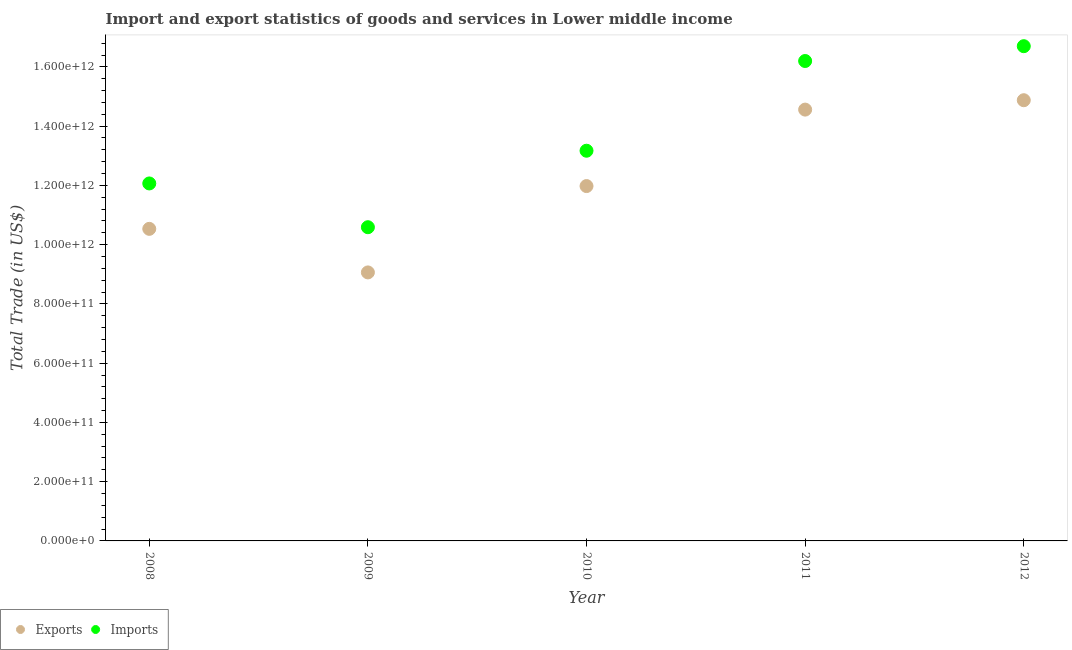Is the number of dotlines equal to the number of legend labels?
Give a very brief answer. Yes. What is the export of goods and services in 2008?
Your response must be concise. 1.05e+12. Across all years, what is the maximum export of goods and services?
Give a very brief answer. 1.49e+12. Across all years, what is the minimum export of goods and services?
Give a very brief answer. 9.06e+11. In which year was the export of goods and services maximum?
Provide a succinct answer. 2012. In which year was the imports of goods and services minimum?
Provide a short and direct response. 2009. What is the total export of goods and services in the graph?
Your answer should be compact. 6.10e+12. What is the difference between the export of goods and services in 2010 and that in 2011?
Offer a very short reply. -2.58e+11. What is the difference between the imports of goods and services in 2011 and the export of goods and services in 2008?
Your response must be concise. 5.67e+11. What is the average export of goods and services per year?
Provide a short and direct response. 1.22e+12. In the year 2012, what is the difference between the imports of goods and services and export of goods and services?
Keep it short and to the point. 1.82e+11. In how many years, is the export of goods and services greater than 840000000000 US$?
Provide a short and direct response. 5. What is the ratio of the export of goods and services in 2008 to that in 2012?
Your answer should be very brief. 0.71. What is the difference between the highest and the second highest export of goods and services?
Keep it short and to the point. 3.17e+1. What is the difference between the highest and the lowest export of goods and services?
Your response must be concise. 5.81e+11. Is the export of goods and services strictly greater than the imports of goods and services over the years?
Keep it short and to the point. No. How many dotlines are there?
Your answer should be compact. 2. How many years are there in the graph?
Provide a short and direct response. 5. What is the difference between two consecutive major ticks on the Y-axis?
Keep it short and to the point. 2.00e+11. Does the graph contain any zero values?
Provide a succinct answer. No. Where does the legend appear in the graph?
Keep it short and to the point. Bottom left. How are the legend labels stacked?
Your answer should be very brief. Horizontal. What is the title of the graph?
Offer a terse response. Import and export statistics of goods and services in Lower middle income. What is the label or title of the Y-axis?
Give a very brief answer. Total Trade (in US$). What is the Total Trade (in US$) in Exports in 2008?
Your answer should be very brief. 1.05e+12. What is the Total Trade (in US$) of Imports in 2008?
Offer a very short reply. 1.21e+12. What is the Total Trade (in US$) in Exports in 2009?
Keep it short and to the point. 9.06e+11. What is the Total Trade (in US$) in Imports in 2009?
Your answer should be compact. 1.06e+12. What is the Total Trade (in US$) of Exports in 2010?
Offer a very short reply. 1.20e+12. What is the Total Trade (in US$) in Imports in 2010?
Make the answer very short. 1.32e+12. What is the Total Trade (in US$) in Exports in 2011?
Your answer should be compact. 1.46e+12. What is the Total Trade (in US$) in Imports in 2011?
Provide a short and direct response. 1.62e+12. What is the Total Trade (in US$) of Exports in 2012?
Provide a succinct answer. 1.49e+12. What is the Total Trade (in US$) in Imports in 2012?
Provide a short and direct response. 1.67e+12. Across all years, what is the maximum Total Trade (in US$) of Exports?
Make the answer very short. 1.49e+12. Across all years, what is the maximum Total Trade (in US$) in Imports?
Your response must be concise. 1.67e+12. Across all years, what is the minimum Total Trade (in US$) of Exports?
Offer a terse response. 9.06e+11. Across all years, what is the minimum Total Trade (in US$) in Imports?
Make the answer very short. 1.06e+12. What is the total Total Trade (in US$) of Exports in the graph?
Offer a very short reply. 6.10e+12. What is the total Total Trade (in US$) in Imports in the graph?
Provide a short and direct response. 6.87e+12. What is the difference between the Total Trade (in US$) of Exports in 2008 and that in 2009?
Offer a very short reply. 1.47e+11. What is the difference between the Total Trade (in US$) of Imports in 2008 and that in 2009?
Offer a very short reply. 1.48e+11. What is the difference between the Total Trade (in US$) of Exports in 2008 and that in 2010?
Your answer should be very brief. -1.44e+11. What is the difference between the Total Trade (in US$) in Imports in 2008 and that in 2010?
Make the answer very short. -1.10e+11. What is the difference between the Total Trade (in US$) in Exports in 2008 and that in 2011?
Provide a succinct answer. -4.02e+11. What is the difference between the Total Trade (in US$) in Imports in 2008 and that in 2011?
Keep it short and to the point. -4.13e+11. What is the difference between the Total Trade (in US$) in Exports in 2008 and that in 2012?
Offer a terse response. -4.34e+11. What is the difference between the Total Trade (in US$) of Imports in 2008 and that in 2012?
Keep it short and to the point. -4.63e+11. What is the difference between the Total Trade (in US$) in Exports in 2009 and that in 2010?
Provide a short and direct response. -2.91e+11. What is the difference between the Total Trade (in US$) of Imports in 2009 and that in 2010?
Offer a very short reply. -2.58e+11. What is the difference between the Total Trade (in US$) in Exports in 2009 and that in 2011?
Ensure brevity in your answer.  -5.49e+11. What is the difference between the Total Trade (in US$) in Imports in 2009 and that in 2011?
Offer a terse response. -5.61e+11. What is the difference between the Total Trade (in US$) of Exports in 2009 and that in 2012?
Your answer should be compact. -5.81e+11. What is the difference between the Total Trade (in US$) in Imports in 2009 and that in 2012?
Offer a very short reply. -6.11e+11. What is the difference between the Total Trade (in US$) in Exports in 2010 and that in 2011?
Your answer should be very brief. -2.58e+11. What is the difference between the Total Trade (in US$) in Imports in 2010 and that in 2011?
Keep it short and to the point. -3.03e+11. What is the difference between the Total Trade (in US$) in Exports in 2010 and that in 2012?
Your answer should be compact. -2.90e+11. What is the difference between the Total Trade (in US$) in Imports in 2010 and that in 2012?
Provide a short and direct response. -3.53e+11. What is the difference between the Total Trade (in US$) in Exports in 2011 and that in 2012?
Provide a succinct answer. -3.17e+1. What is the difference between the Total Trade (in US$) in Imports in 2011 and that in 2012?
Your answer should be compact. -5.00e+1. What is the difference between the Total Trade (in US$) in Exports in 2008 and the Total Trade (in US$) in Imports in 2009?
Provide a short and direct response. -5.53e+09. What is the difference between the Total Trade (in US$) of Exports in 2008 and the Total Trade (in US$) of Imports in 2010?
Your answer should be compact. -2.64e+11. What is the difference between the Total Trade (in US$) of Exports in 2008 and the Total Trade (in US$) of Imports in 2011?
Provide a succinct answer. -5.67e+11. What is the difference between the Total Trade (in US$) in Exports in 2008 and the Total Trade (in US$) in Imports in 2012?
Give a very brief answer. -6.17e+11. What is the difference between the Total Trade (in US$) of Exports in 2009 and the Total Trade (in US$) of Imports in 2010?
Ensure brevity in your answer.  -4.11e+11. What is the difference between the Total Trade (in US$) of Exports in 2009 and the Total Trade (in US$) of Imports in 2011?
Offer a very short reply. -7.14e+11. What is the difference between the Total Trade (in US$) of Exports in 2009 and the Total Trade (in US$) of Imports in 2012?
Your response must be concise. -7.64e+11. What is the difference between the Total Trade (in US$) in Exports in 2010 and the Total Trade (in US$) in Imports in 2011?
Offer a very short reply. -4.22e+11. What is the difference between the Total Trade (in US$) of Exports in 2010 and the Total Trade (in US$) of Imports in 2012?
Offer a terse response. -4.72e+11. What is the difference between the Total Trade (in US$) of Exports in 2011 and the Total Trade (in US$) of Imports in 2012?
Offer a very short reply. -2.14e+11. What is the average Total Trade (in US$) in Exports per year?
Offer a very short reply. 1.22e+12. What is the average Total Trade (in US$) of Imports per year?
Your response must be concise. 1.37e+12. In the year 2008, what is the difference between the Total Trade (in US$) of Exports and Total Trade (in US$) of Imports?
Offer a terse response. -1.53e+11. In the year 2009, what is the difference between the Total Trade (in US$) of Exports and Total Trade (in US$) of Imports?
Ensure brevity in your answer.  -1.53e+11. In the year 2010, what is the difference between the Total Trade (in US$) of Exports and Total Trade (in US$) of Imports?
Your answer should be very brief. -1.19e+11. In the year 2011, what is the difference between the Total Trade (in US$) in Exports and Total Trade (in US$) in Imports?
Ensure brevity in your answer.  -1.64e+11. In the year 2012, what is the difference between the Total Trade (in US$) of Exports and Total Trade (in US$) of Imports?
Your response must be concise. -1.82e+11. What is the ratio of the Total Trade (in US$) of Exports in 2008 to that in 2009?
Your answer should be compact. 1.16. What is the ratio of the Total Trade (in US$) of Imports in 2008 to that in 2009?
Your response must be concise. 1.14. What is the ratio of the Total Trade (in US$) in Exports in 2008 to that in 2010?
Ensure brevity in your answer.  0.88. What is the ratio of the Total Trade (in US$) of Imports in 2008 to that in 2010?
Offer a very short reply. 0.92. What is the ratio of the Total Trade (in US$) in Exports in 2008 to that in 2011?
Your answer should be compact. 0.72. What is the ratio of the Total Trade (in US$) of Imports in 2008 to that in 2011?
Give a very brief answer. 0.74. What is the ratio of the Total Trade (in US$) of Exports in 2008 to that in 2012?
Give a very brief answer. 0.71. What is the ratio of the Total Trade (in US$) in Imports in 2008 to that in 2012?
Provide a succinct answer. 0.72. What is the ratio of the Total Trade (in US$) of Exports in 2009 to that in 2010?
Offer a very short reply. 0.76. What is the ratio of the Total Trade (in US$) in Imports in 2009 to that in 2010?
Provide a short and direct response. 0.8. What is the ratio of the Total Trade (in US$) in Exports in 2009 to that in 2011?
Keep it short and to the point. 0.62. What is the ratio of the Total Trade (in US$) in Imports in 2009 to that in 2011?
Provide a short and direct response. 0.65. What is the ratio of the Total Trade (in US$) of Exports in 2009 to that in 2012?
Keep it short and to the point. 0.61. What is the ratio of the Total Trade (in US$) of Imports in 2009 to that in 2012?
Your answer should be very brief. 0.63. What is the ratio of the Total Trade (in US$) in Exports in 2010 to that in 2011?
Offer a very short reply. 0.82. What is the ratio of the Total Trade (in US$) in Imports in 2010 to that in 2011?
Give a very brief answer. 0.81. What is the ratio of the Total Trade (in US$) of Exports in 2010 to that in 2012?
Make the answer very short. 0.81. What is the ratio of the Total Trade (in US$) in Imports in 2010 to that in 2012?
Keep it short and to the point. 0.79. What is the ratio of the Total Trade (in US$) in Exports in 2011 to that in 2012?
Give a very brief answer. 0.98. What is the ratio of the Total Trade (in US$) of Imports in 2011 to that in 2012?
Your answer should be very brief. 0.97. What is the difference between the highest and the second highest Total Trade (in US$) in Exports?
Provide a short and direct response. 3.17e+1. What is the difference between the highest and the second highest Total Trade (in US$) in Imports?
Provide a short and direct response. 5.00e+1. What is the difference between the highest and the lowest Total Trade (in US$) of Exports?
Provide a short and direct response. 5.81e+11. What is the difference between the highest and the lowest Total Trade (in US$) in Imports?
Give a very brief answer. 6.11e+11. 